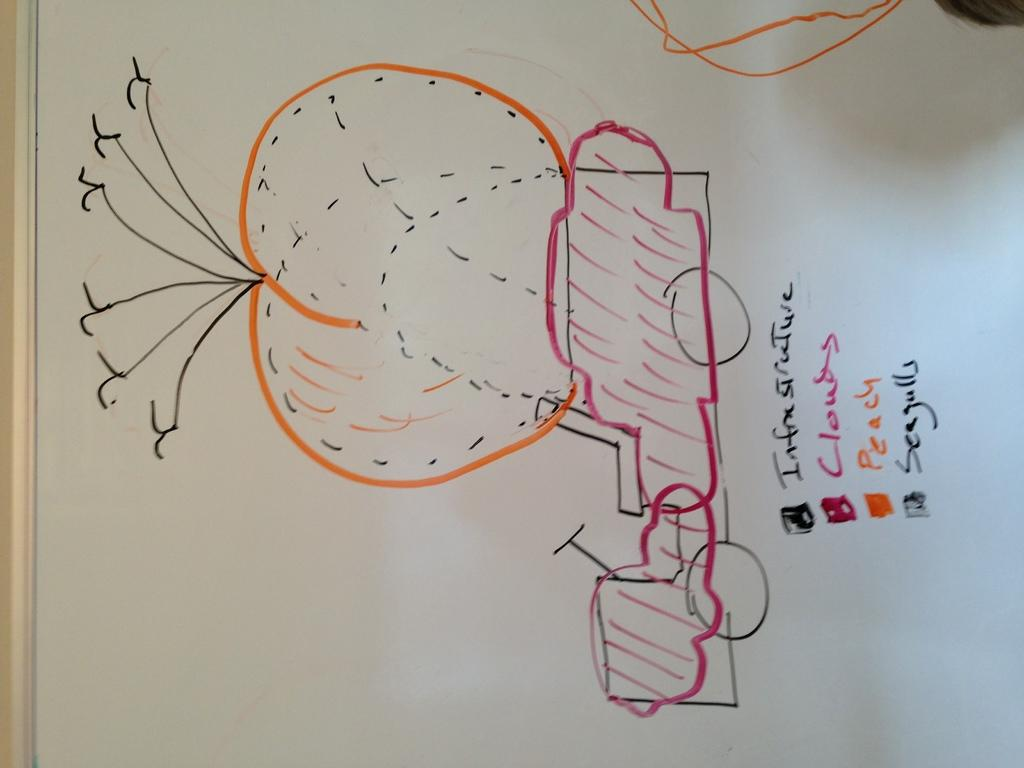<image>
Provide a brief description of the given image. Different colors in a drawing signify things such as clouds and seagulls. 